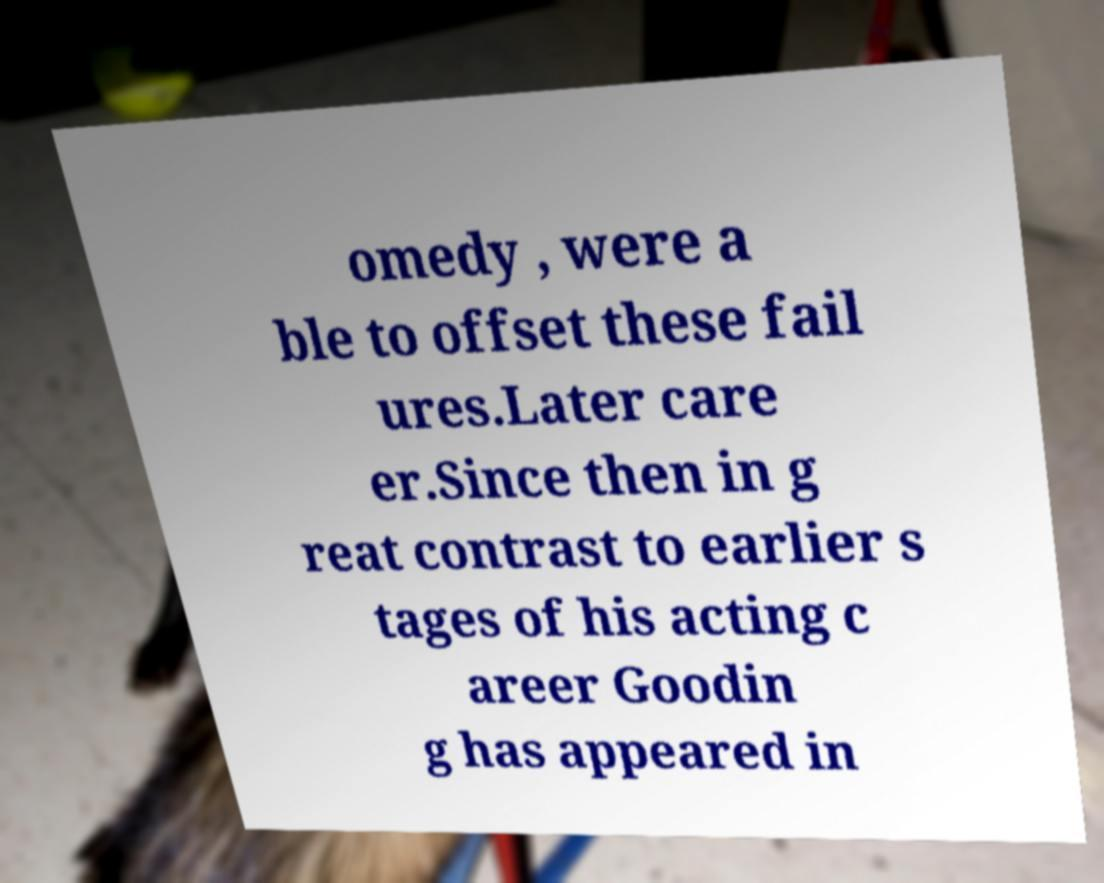There's text embedded in this image that I need extracted. Can you transcribe it verbatim? omedy , were a ble to offset these fail ures.Later care er.Since then in g reat contrast to earlier s tages of his acting c areer Goodin g has appeared in 